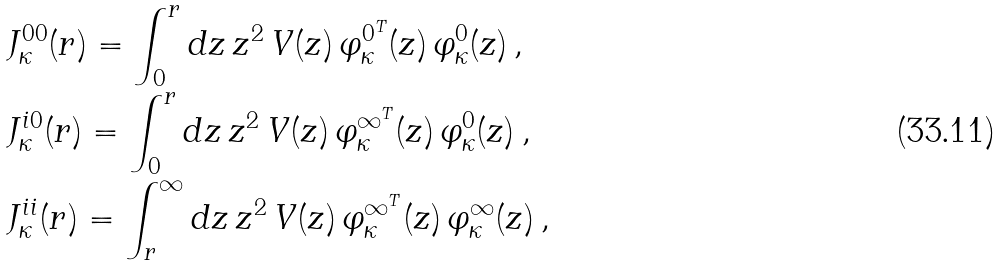Convert formula to latex. <formula><loc_0><loc_0><loc_500><loc_500>& J _ { \kappa } ^ { 0 0 } ( r ) = \int _ { 0 } ^ { r } d z \, z ^ { 2 } \, V ( z ) \, \varphi ^ { 0 ^ { T } } _ { \kappa } ( z ) \, \varphi ^ { 0 } _ { \kappa } ( z ) \, , \\ & J _ { \kappa } ^ { i 0 } ( r ) = \int _ { 0 } ^ { r } d z \, z ^ { 2 } \, V ( z ) \, \varphi ^ { { \infty } ^ { T } } _ { \kappa } ( z ) \, \varphi ^ { 0 } _ { \kappa } ( z ) \, , \\ & J _ { \kappa } ^ { i i } ( r ) = \int _ { r } ^ { \infty } d z \, z ^ { 2 } \, V ( z ) \, \varphi ^ { { \infty } ^ { T } } _ { \kappa } ( z ) \, \varphi ^ { \infty } _ { \kappa } ( z ) \, ,</formula> 